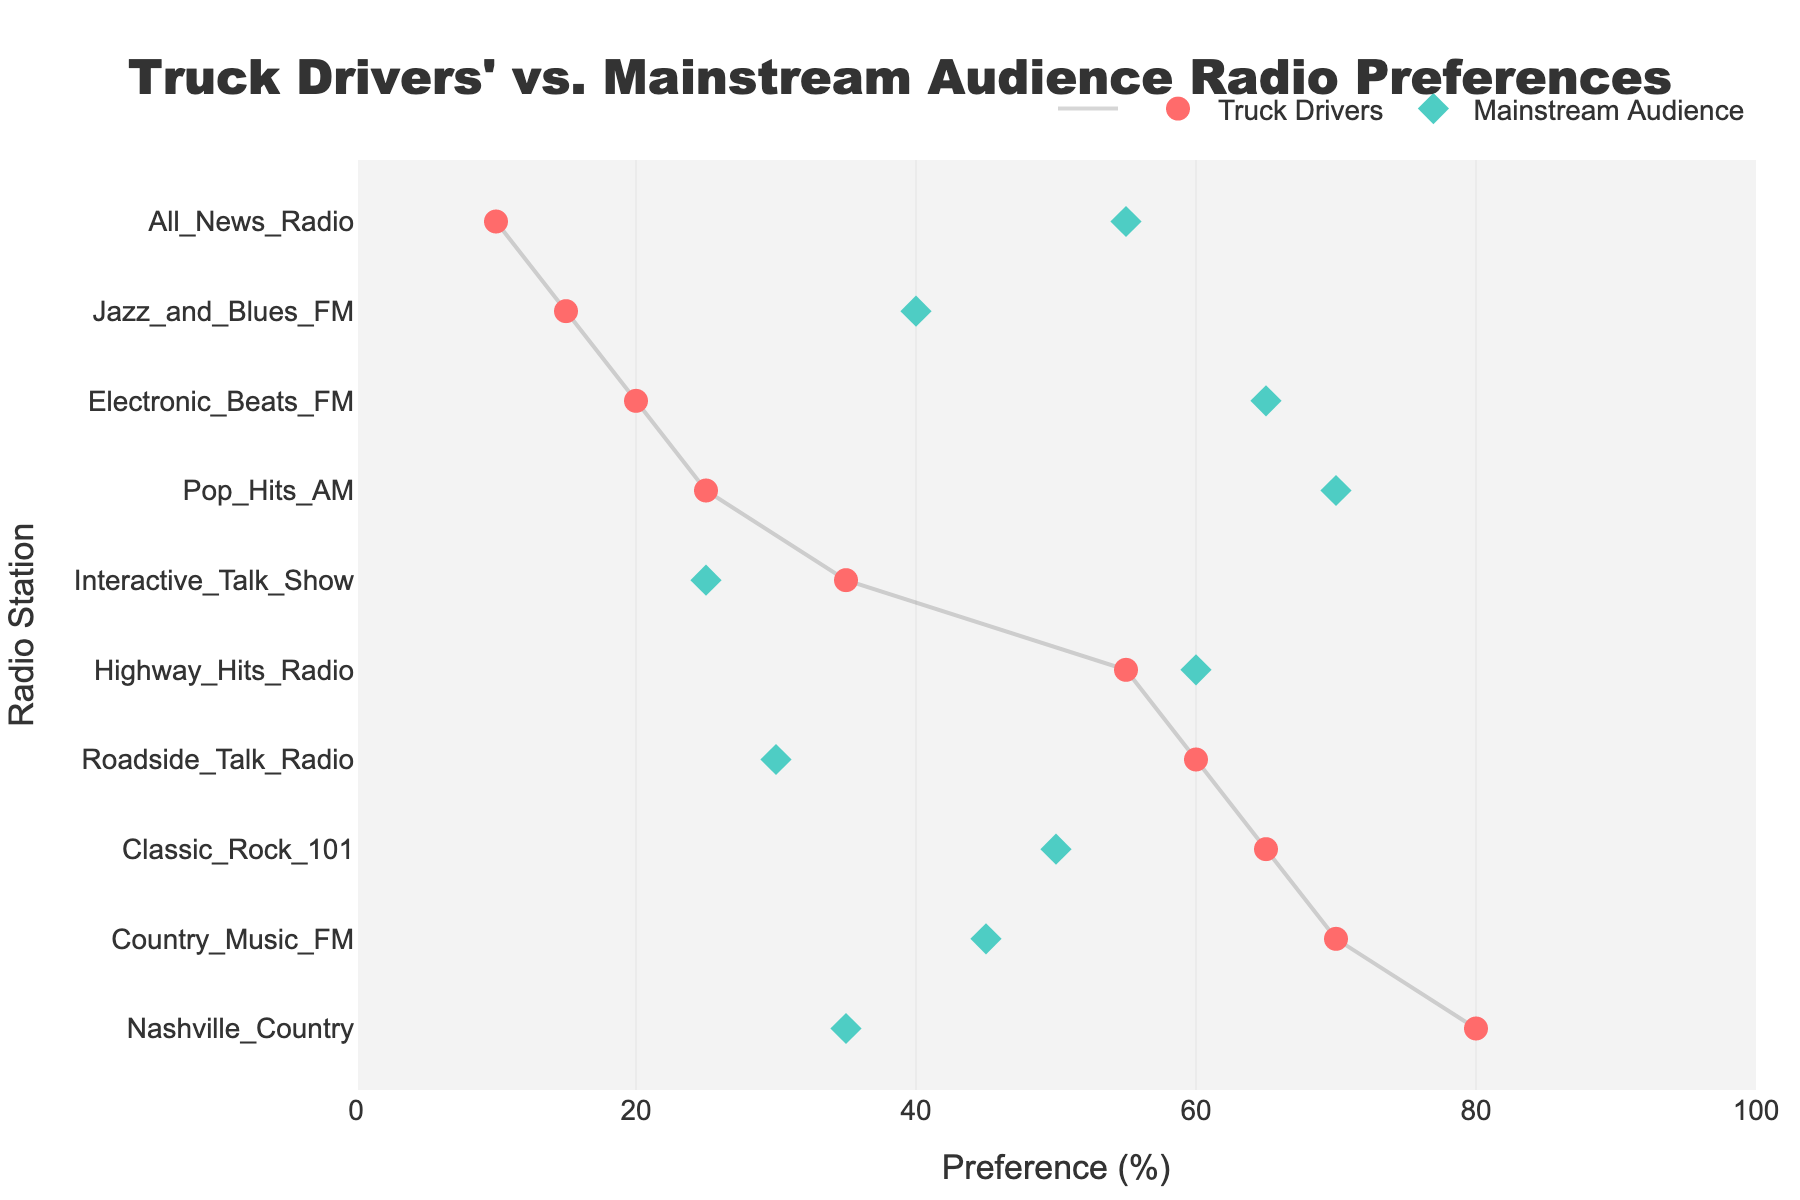what is the title of the plot? The title is located at the top center of the plot. It reads "Truck Drivers' vs. Mainstream Audience Radio Preferences".
Answer: Truck Drivers' vs. Mainstream Audience Radio Preferences How many radio stations prefer Truck Drivers over the Mainstream Audience? To answer this, we should count the radio stations where the percentage of preferences for Truck Drivers is greater than that for the Mainstream Audience. These stations are "Country Music FM", "Classic Rock 101", "Roadside Talk Radio", "Nashville Country", "Interactive Talk Show".
Answer: 5 Which radio station has the highest preference among Truck Drivers? Look at the markers color-coded for Truck Drivers and find the station with the maximum value on the x-axis, which is 80 for "Nashville Country".
Answer: Nashville Country For the radio station "Highway Hits Radio", which audience has a higher preference? Locate "Highway Hits Radio" on the y-axis and compare the points on the x-axis for both Truck Drivers (55) and Mainstream Audience (60).
Answer: Mainstream Audience Which radio station shows the biggest disparity in preferences between Truck Drivers and the Mainstream Audience? Calculate the differences between preferences for each radio station and identify the one with the largest value. For "Roadside Talk Radio," the difference is 60 - 30 = 30.
Answer: Roadside Talk Radio What is the range of preference values for Truck Drivers? Find the minimum and maximum preference values for Truck Drivers, which are 10 for "All News Radio" and 80 for "Nashville Country".
Answer: 10-80 What is the average preference for Mainstream Audience for radio stations preferred by Truck Drivers? Only consider stations preferred by Truck Drivers (5 identified in question 2). Average these Mainstream Audience preferences: 45, 50, 30, 35, 25. The average is (45 + 50 + 30 + 35 + 25)/5 = 37.
Answer: 37 Which radio station is least preferred by Truck Drivers? Locate the radio station with the lowest value on the x-axis for Truck Drivers, which is 10 for "All News Radio".
Answer: All News Radio Which radio station has almost equal preferences from both Truck Drivers and the Mainstream Audience? Identify radio stations where preference percentages are very close, such as "Interactive Talk Show" with preferences 35 (Truck Drivers) and 25 (Mainstream Audience).
Answer: Interactive Talk Show List the radio stations where Mainstream Audience preference is more than double that of Truck Drivers. Find stations where the mainstream audience's preference is more than twice that of Truck Drivers. "Pop Hits AM" has 70 versus 25, and "All News Radio" has 55 versus 10.
Answer: Pop Hits AM, All News Radio 